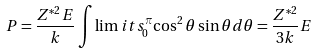Convert formula to latex. <formula><loc_0><loc_0><loc_500><loc_500>P = \frac { Z ^ { * 2 } E } { k } \int \lim i t s _ { 0 } ^ { \pi } { \cos ^ { 2 } \theta \sin \theta d \theta } = \frac { Z ^ { * 2 } } { 3 k } E</formula> 